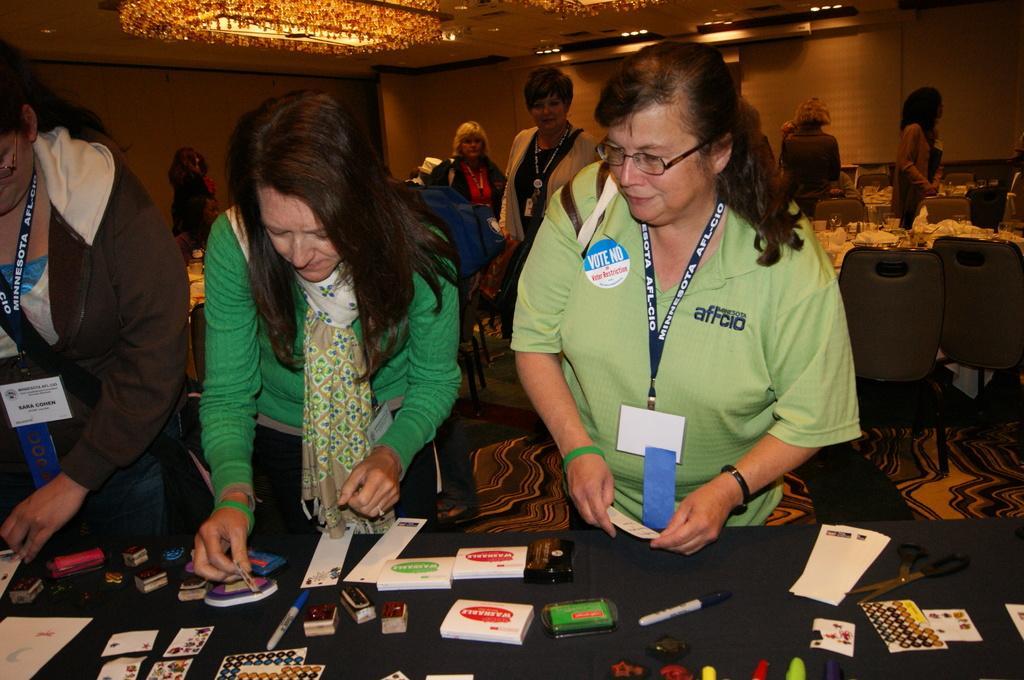Can you describe this image briefly? In this picture we can observe three women. Two of them are wearing blue color tags in their necks. One of them is wearing spectacles. In front of them there is a table on which we can observe some accessories placed. In the background there are some people standing. We can observe lights in the ceiling. 